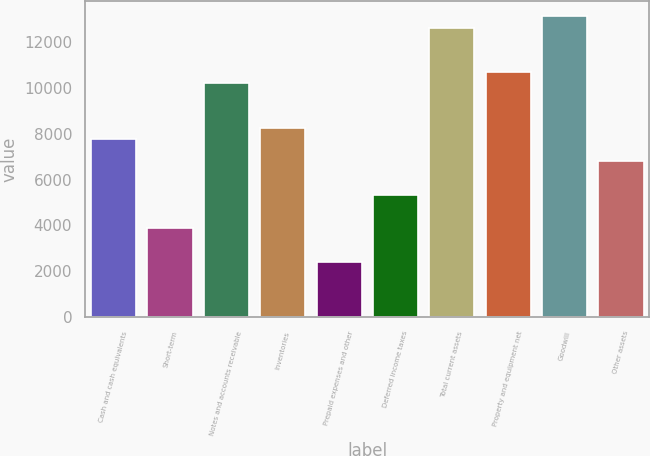<chart> <loc_0><loc_0><loc_500><loc_500><bar_chart><fcel>Cash and cash equivalents<fcel>Short-term<fcel>Notes and accounts receivable<fcel>Inventories<fcel>Prepaid expenses and other<fcel>Deferred income taxes<fcel>Total current assets<fcel>Property and equipment net<fcel>Goodwill<fcel>Other assets<nl><fcel>7767.46<fcel>3884.18<fcel>10194.5<fcel>8252.87<fcel>2427.95<fcel>5340.41<fcel>12621.6<fcel>10679.9<fcel>13107<fcel>6796.64<nl></chart> 